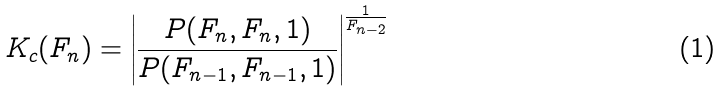<formula> <loc_0><loc_0><loc_500><loc_500>K _ { c } ( F _ { n } ) = \left | \frac { P ( F _ { n } , F _ { n } , 1 ) } { P ( F _ { n - 1 } , F _ { n - 1 } , 1 ) } \right | ^ { \frac { 1 } { F _ { n - 2 } } }</formula> 